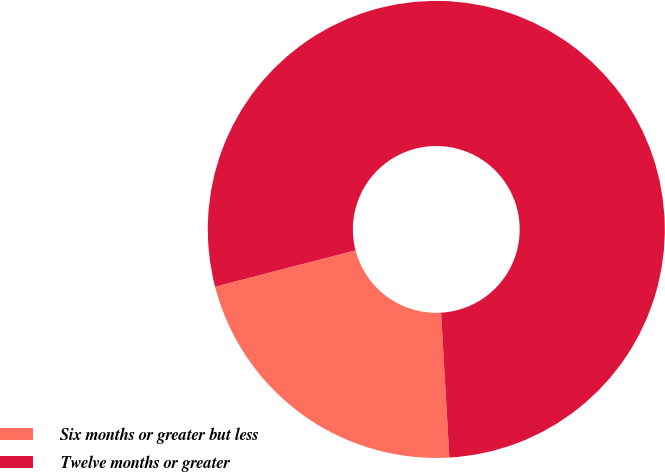Convert chart to OTSL. <chart><loc_0><loc_0><loc_500><loc_500><pie_chart><fcel>Six months or greater but less<fcel>Twelve months or greater<nl><fcel>21.88%<fcel>78.12%<nl></chart> 